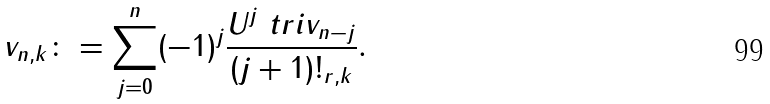Convert formula to latex. <formula><loc_0><loc_0><loc_500><loc_500>\ v _ { n , k } \colon = \sum _ { j = 0 } ^ { n } ( - 1 ) ^ { j } \frac { U ^ { j } \ t r i v _ { n - j } } { ( j + 1 ) ! _ { r , k } } .</formula> 